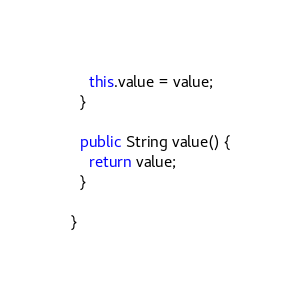Convert code to text. <code><loc_0><loc_0><loc_500><loc_500><_Java_>    this.value = value;
  }

  public String value() {
    return value;
  }

}</code> 